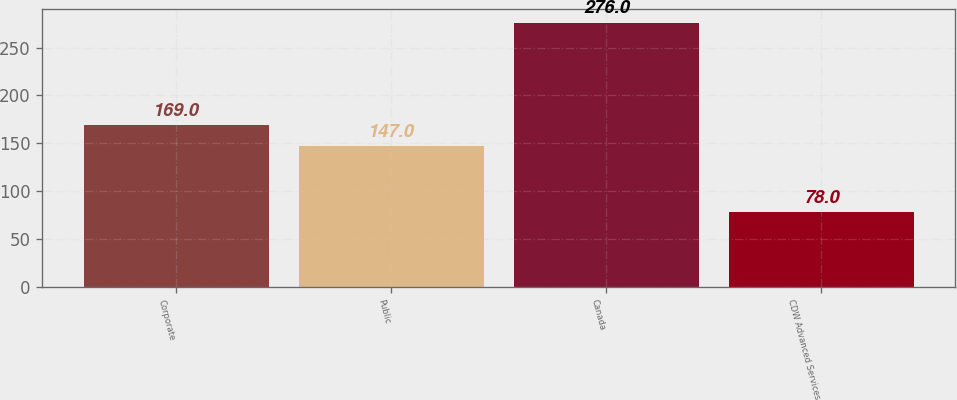Convert chart to OTSL. <chart><loc_0><loc_0><loc_500><loc_500><bar_chart><fcel>Corporate<fcel>Public<fcel>Canada<fcel>CDW Advanced Services<nl><fcel>169<fcel>147<fcel>276<fcel>78<nl></chart> 